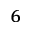<formula> <loc_0><loc_0><loc_500><loc_500>^ { 6 }</formula> 